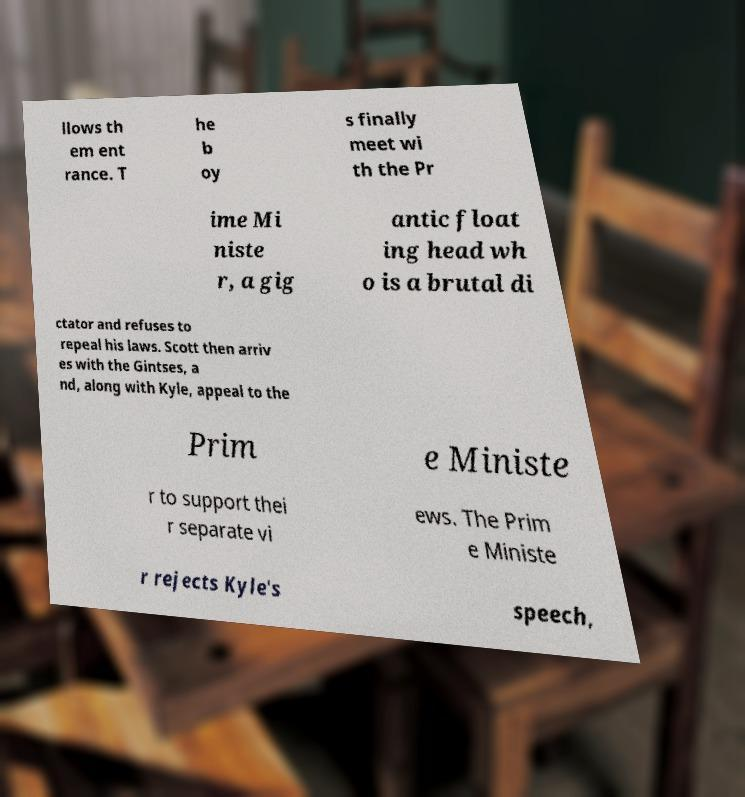Can you read and provide the text displayed in the image?This photo seems to have some interesting text. Can you extract and type it out for me? llows th em ent rance. T he b oy s finally meet wi th the Pr ime Mi niste r, a gig antic float ing head wh o is a brutal di ctator and refuses to repeal his laws. Scott then arriv es with the Gintses, a nd, along with Kyle, appeal to the Prim e Ministe r to support thei r separate vi ews. The Prim e Ministe r rejects Kyle's speech, 